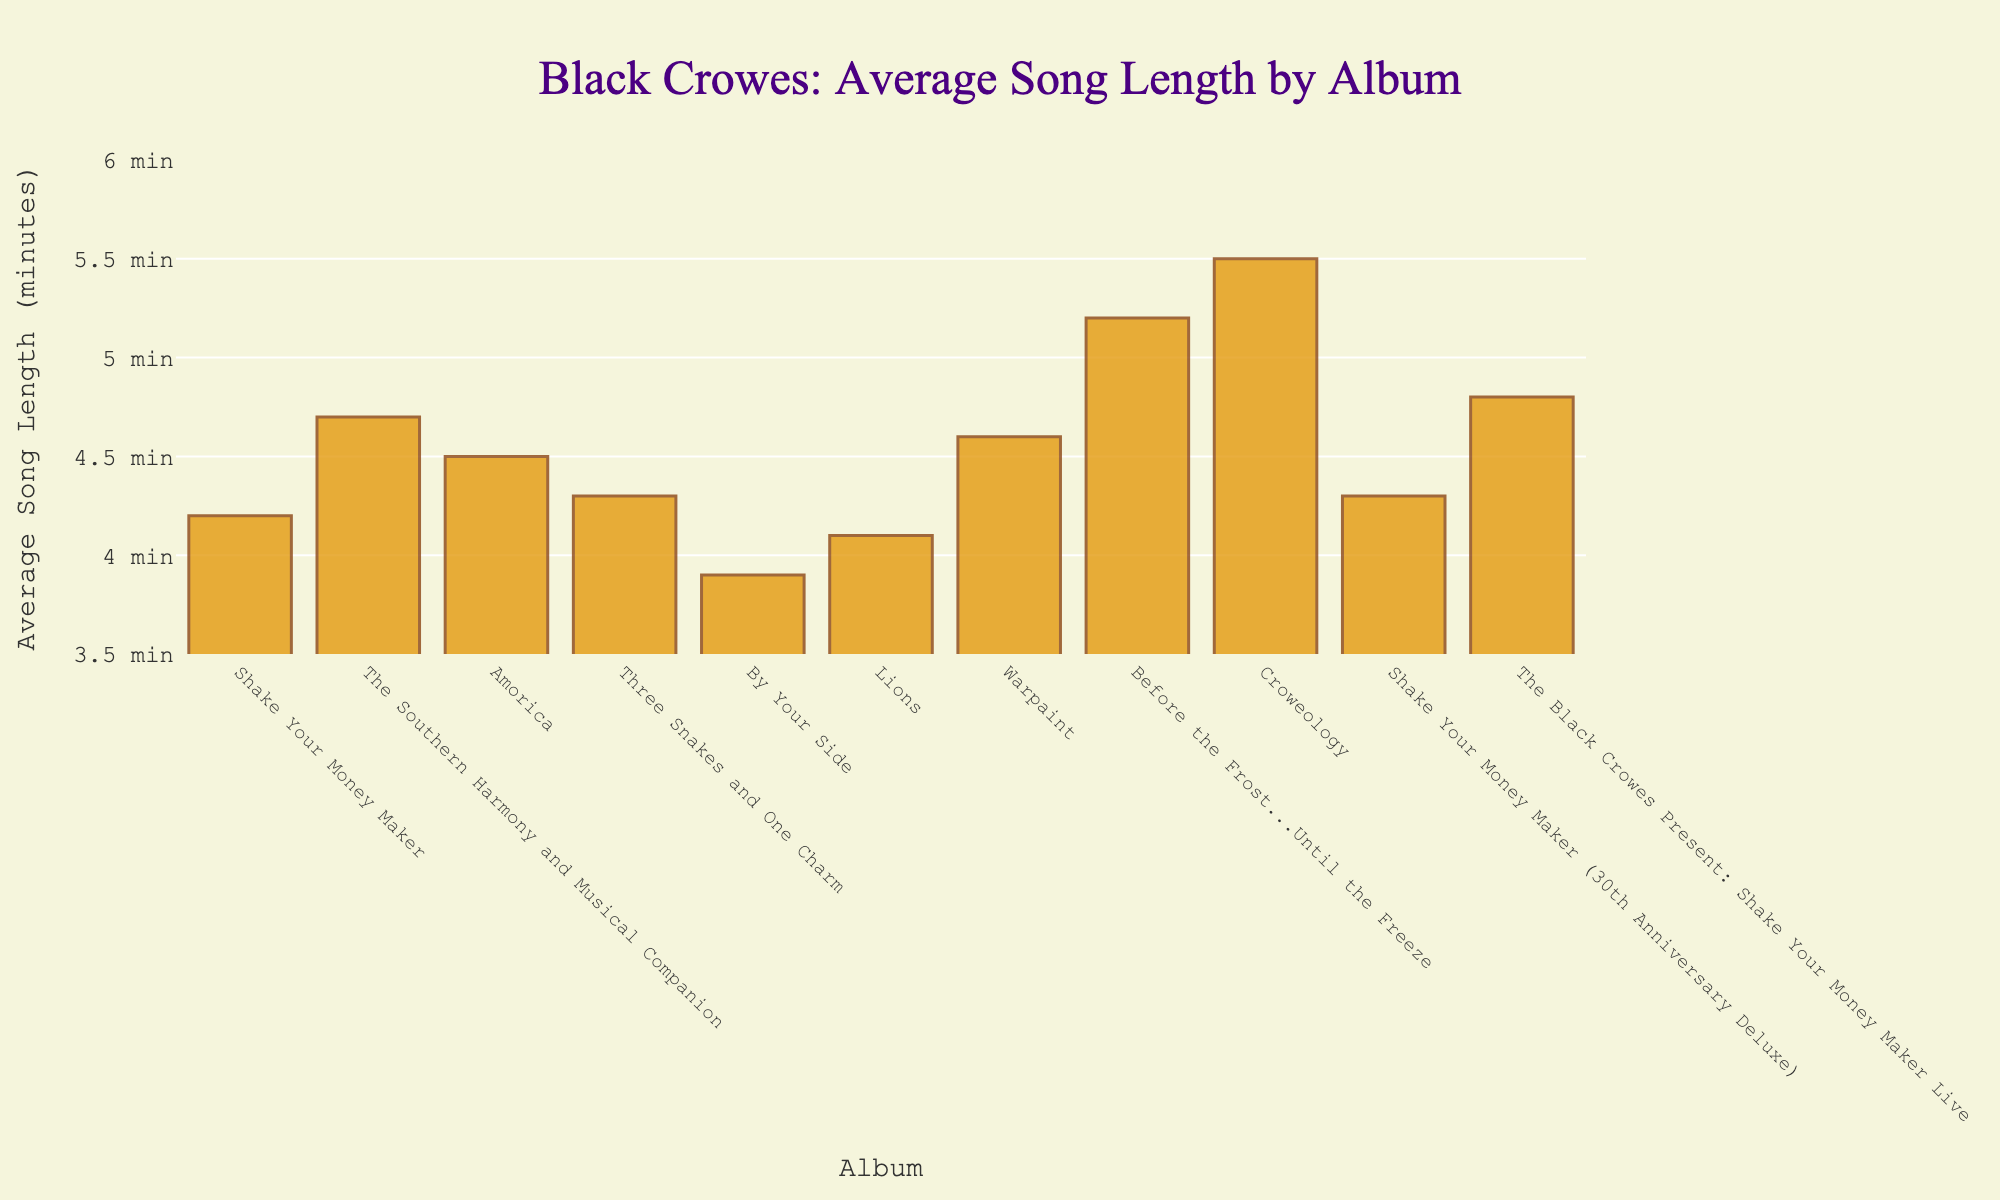What's the average song length for 'The Southern Harmony and Musical Companion'? Look at the bar corresponding to 'The Southern Harmony and Musical Companion' on the x-axis and read the y-axis value
Answer: 4.7 minutes Which album has the longest average song length? Identify the tallest bar in the chart and read the album name on the x-axis
Answer: Croweology What is the difference in average song length between 'Before the Frost...Until the Freeze' and 'By Your Side'? Subtract the length of 'By Your Side' (3.9 minutes) from 'Before the Frost...Until the Freeze' (5.2 minutes): 5.2 - 3.9 = 1.3 minutes
Answer: 1.3 minutes How many albums have an average song length of 4.5 minutes or more? Count the number of bars with a height of 4.5 or more by looking at the y-axis values
Answer: 7 albums Which album has a shorter average song length: 'Black Crowes Present: Shake Your Money Maker Live' or 'Warpaint'? Compare the heights of the bars corresponding to each album; 'Black Crowes Present: Shake Your Money Maker Live' is 4.8 minutes, and 'Warpaint' is 4.6 minutes
Answer: Warpaint What is the combined average song length of 'Shake Your Money Maker' and 'Lions'? Sum the average song lengths of 'Shake Your Money Maker' (4.2 minutes) and 'Lions' (4.1 minutes): 4.2 + 4.1 = 8.3 minutes
Answer: 8.3 minutes Which album has a higher average song length: 'Amorica' or 'Three Snakes and One Charm'? Compare the heights of the bars for 'Amorica' (4.5 minutes) and 'Three Snakes and One Charm' (4.3 minutes)
Answer: Amorica Is the average song length for 'Shake Your Money Maker (30th Anniversary Deluxe)' greater than the average song length for 'Shake Your Money Maker'? Compare the heights of the bars: 'Shake Your Money Maker (30th Anniversary Deluxe)' is 4.3 minutes, and 'Shake Your Money Maker' is 4.2 minutes
Answer: Yes What is the height difference between the tallest and shortest bars in the chart? Identify the tallest bar (Croweology at 5.5 minutes) and the shortest bar (By Your Side at 3.9 minutes) then subtract 3.9 from 5.5: 5.5 - 3.9 = 1.6 minutes
Answer: 1.6 minutes 